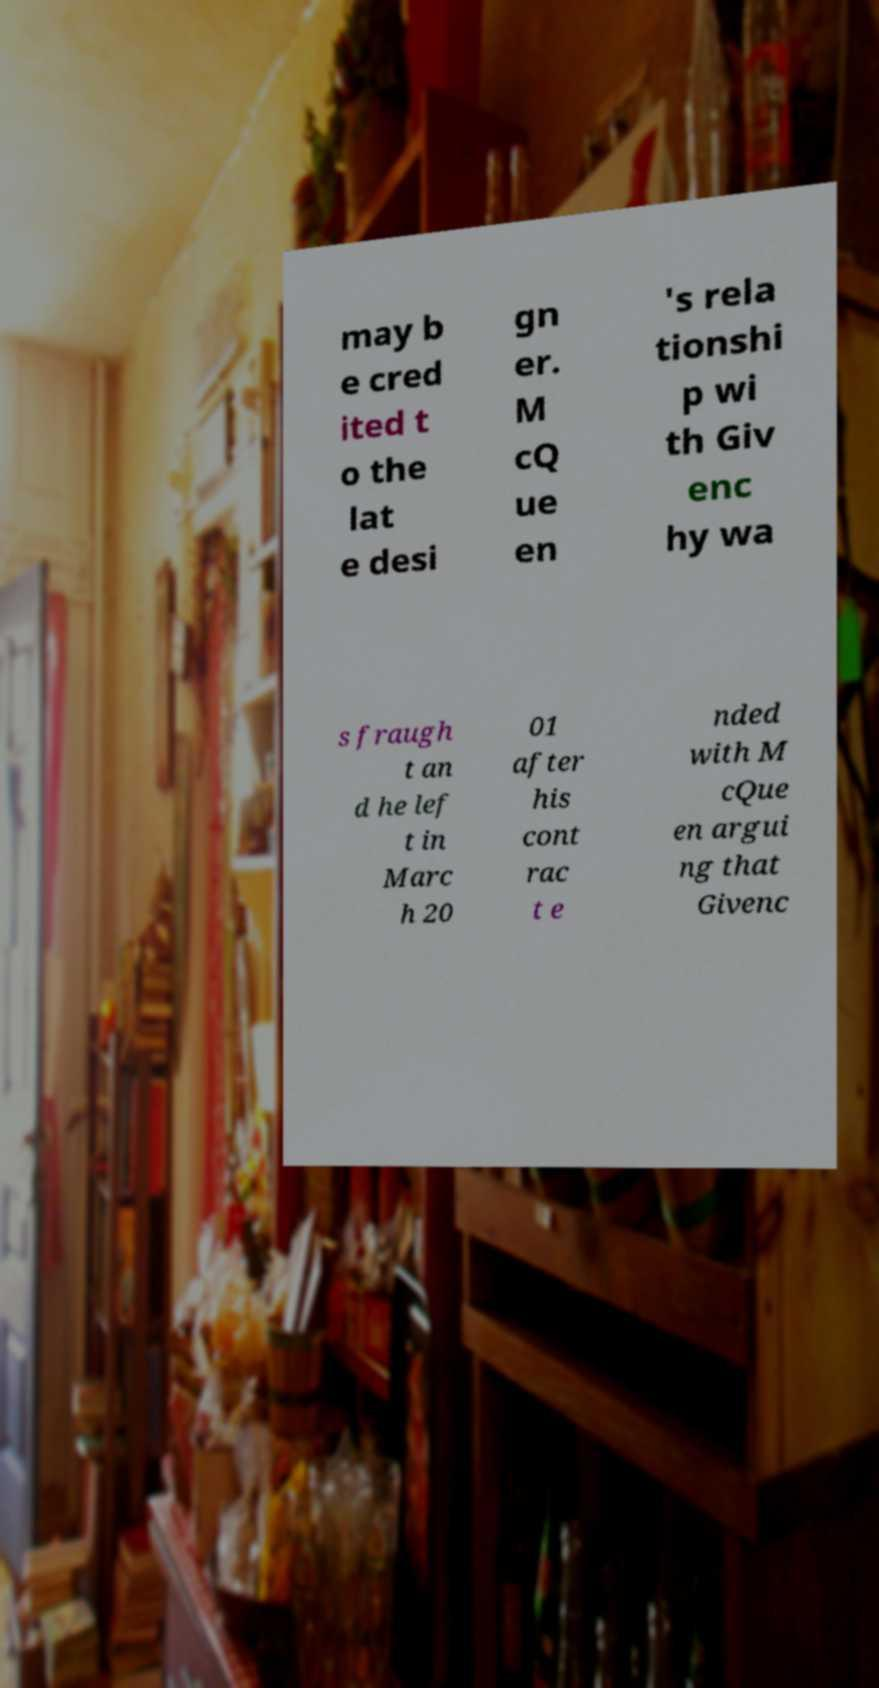What messages or text are displayed in this image? I need them in a readable, typed format. may b e cred ited t o the lat e desi gn er. M cQ ue en 's rela tionshi p wi th Giv enc hy wa s fraugh t an d he lef t in Marc h 20 01 after his cont rac t e nded with M cQue en argui ng that Givenc 